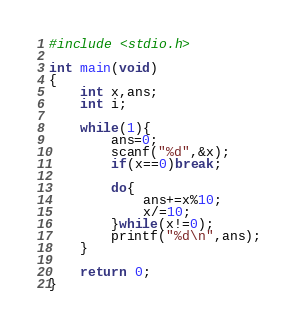Convert code to text. <code><loc_0><loc_0><loc_500><loc_500><_C_>#include <stdio.h>

int main(void)
{
	int x,ans;
	int i;
	
	while(1){
		ans=0;
		scanf("%d",&x);
		if(x==0)break;
		
		do{
			ans+=x%10;
			x/=10;
		}while(x!=0);
		printf("%d\n",ans);
	}
		
	return 0;
}
</code> 